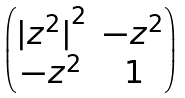<formula> <loc_0><loc_0><loc_500><loc_500>\begin{pmatrix} { | z ^ { 2 } | } ^ { 2 } & - z ^ { 2 } \\ - z ^ { 2 } & 1 \end{pmatrix}</formula> 